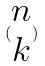<formula> <loc_0><loc_0><loc_500><loc_500>( \begin{matrix} n \\ k \end{matrix} )</formula> 